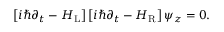<formula> <loc_0><loc_0><loc_500><loc_500>\begin{array} { r } { \left [ i \hbar { \partial } _ { t } - H _ { L } \right ] \left [ i \hbar { \partial } _ { t } - H _ { R } \right ] \psi _ { z } = 0 . } \end{array}</formula> 